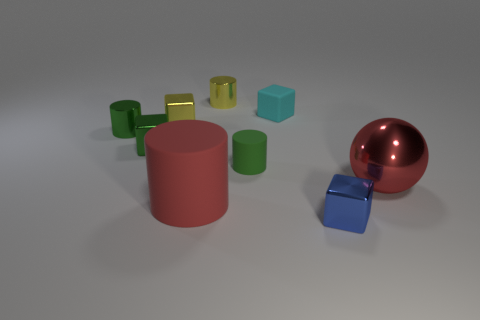There is a small green thing right of the yellow cylinder; how many large matte things are in front of it?
Your answer should be very brief. 1. Are there any blue things that are in front of the block in front of the big thing that is right of the cyan matte cube?
Offer a very short reply. No. There is a green object that is the same shape as the cyan rubber object; what is it made of?
Offer a terse response. Metal. Are there any other things that are the same material as the tiny green cube?
Your response must be concise. Yes. Do the small blue block and the yellow thing in front of the cyan cube have the same material?
Keep it short and to the point. Yes. What shape is the large thing that is to the right of the small metal cylinder that is to the right of the green cube?
Provide a succinct answer. Sphere. What number of tiny things are either rubber spheres or matte things?
Ensure brevity in your answer.  2. How many tiny green shiny things are the same shape as the large rubber thing?
Offer a terse response. 1. Does the tiny blue thing have the same shape as the big red thing to the right of the green rubber cylinder?
Provide a short and direct response. No. What number of small rubber things are behind the cyan object?
Provide a short and direct response. 0. 